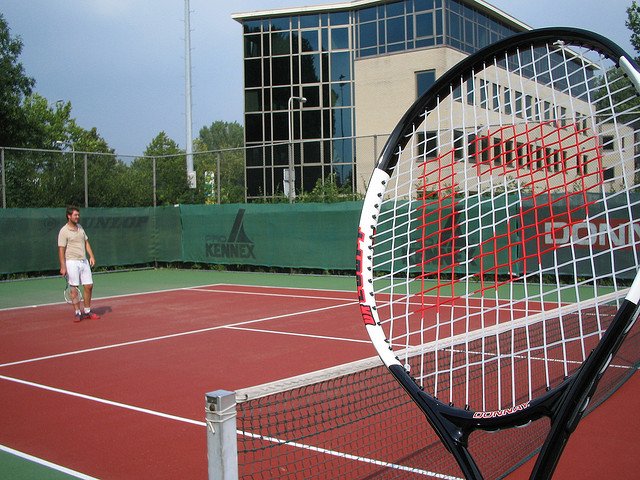Can you describe the environment in which this sport is played? This sport is typically played on a rectangular flat surface known as a tennis court, which can be made from clay, grass, or synthetic surfaces. The court is divided into two equal sides by a net. The image shows an outdoor court with a hard surface, surrounded by a green fence for containing balls and an adjacent building, suggesting this might be a community park or a club. 